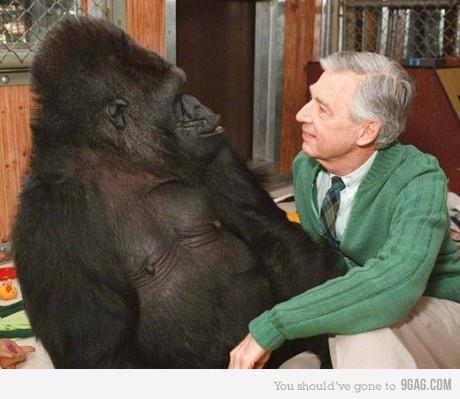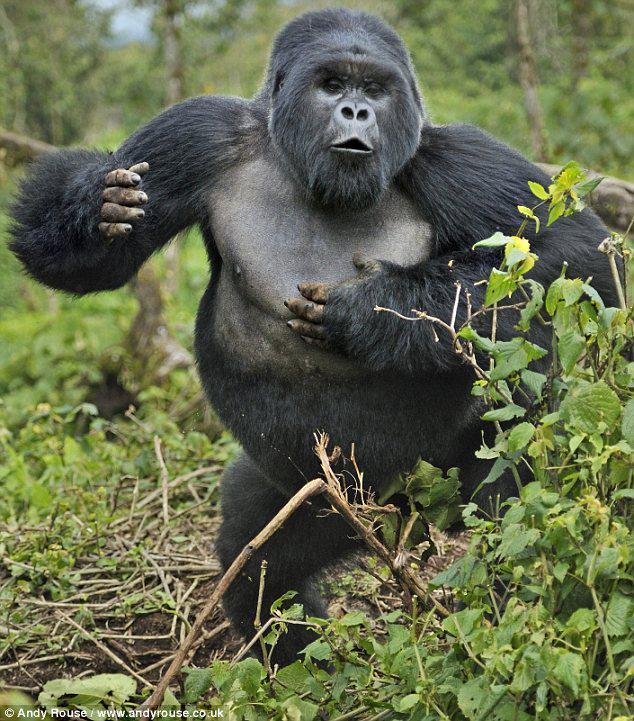The first image is the image on the left, the second image is the image on the right. Analyze the images presented: Is the assertion "There are at most two adult gorillas." valid? Answer yes or no. Yes. The first image is the image on the left, the second image is the image on the right. Assess this claim about the two images: "In one of the images there is one animal all by itself.". Correct or not? Answer yes or no. Yes. 